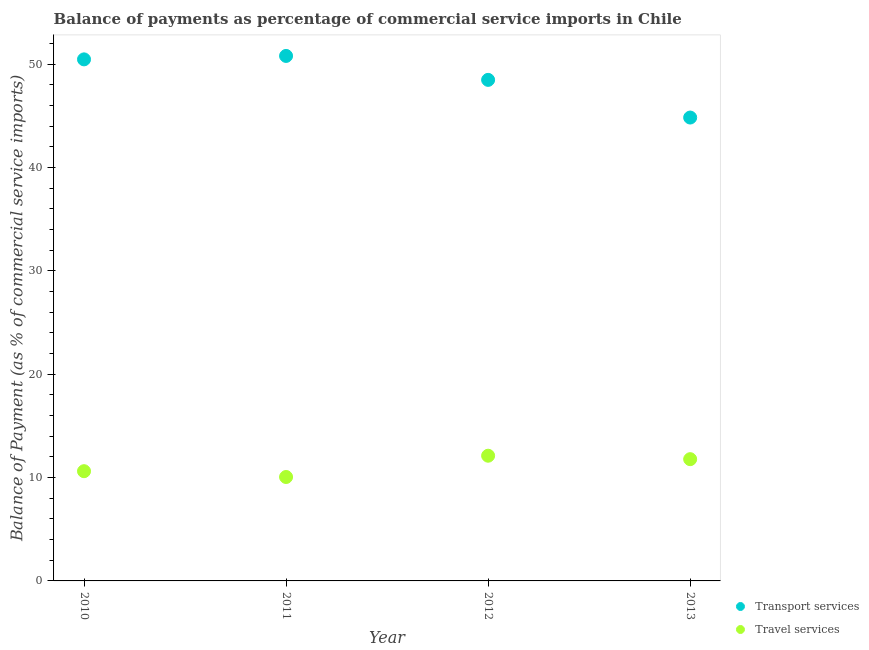How many different coloured dotlines are there?
Give a very brief answer. 2. What is the balance of payments of transport services in 2011?
Provide a succinct answer. 50.78. Across all years, what is the maximum balance of payments of travel services?
Offer a very short reply. 12.11. Across all years, what is the minimum balance of payments of transport services?
Your answer should be very brief. 44.82. In which year was the balance of payments of travel services maximum?
Offer a terse response. 2012. What is the total balance of payments of travel services in the graph?
Provide a succinct answer. 44.56. What is the difference between the balance of payments of travel services in 2010 and that in 2013?
Provide a short and direct response. -1.16. What is the difference between the balance of payments of transport services in 2010 and the balance of payments of travel services in 2012?
Your response must be concise. 38.34. What is the average balance of payments of transport services per year?
Keep it short and to the point. 48.63. In the year 2010, what is the difference between the balance of payments of transport services and balance of payments of travel services?
Offer a very short reply. 39.84. What is the ratio of the balance of payments of transport services in 2011 to that in 2012?
Give a very brief answer. 1.05. What is the difference between the highest and the second highest balance of payments of transport services?
Ensure brevity in your answer.  0.33. What is the difference between the highest and the lowest balance of payments of transport services?
Provide a succinct answer. 5.96. In how many years, is the balance of payments of transport services greater than the average balance of payments of transport services taken over all years?
Offer a terse response. 2. Is the balance of payments of transport services strictly greater than the balance of payments of travel services over the years?
Make the answer very short. Yes. How many dotlines are there?
Make the answer very short. 2. What is the difference between two consecutive major ticks on the Y-axis?
Offer a terse response. 10. Does the graph contain any zero values?
Offer a very short reply. No. Where does the legend appear in the graph?
Keep it short and to the point. Bottom right. How many legend labels are there?
Offer a very short reply. 2. How are the legend labels stacked?
Provide a short and direct response. Vertical. What is the title of the graph?
Offer a very short reply. Balance of payments as percentage of commercial service imports in Chile. Does "Mineral" appear as one of the legend labels in the graph?
Your answer should be very brief. No. What is the label or title of the X-axis?
Keep it short and to the point. Year. What is the label or title of the Y-axis?
Provide a short and direct response. Balance of Payment (as % of commercial service imports). What is the Balance of Payment (as % of commercial service imports) of Transport services in 2010?
Give a very brief answer. 50.45. What is the Balance of Payment (as % of commercial service imports) in Travel services in 2010?
Your answer should be very brief. 10.61. What is the Balance of Payment (as % of commercial service imports) in Transport services in 2011?
Offer a terse response. 50.78. What is the Balance of Payment (as % of commercial service imports) of Travel services in 2011?
Provide a short and direct response. 10.05. What is the Balance of Payment (as % of commercial service imports) in Transport services in 2012?
Ensure brevity in your answer.  48.47. What is the Balance of Payment (as % of commercial service imports) in Travel services in 2012?
Your answer should be very brief. 12.11. What is the Balance of Payment (as % of commercial service imports) in Transport services in 2013?
Your response must be concise. 44.82. What is the Balance of Payment (as % of commercial service imports) of Travel services in 2013?
Your answer should be compact. 11.78. Across all years, what is the maximum Balance of Payment (as % of commercial service imports) in Transport services?
Provide a short and direct response. 50.78. Across all years, what is the maximum Balance of Payment (as % of commercial service imports) of Travel services?
Offer a terse response. 12.11. Across all years, what is the minimum Balance of Payment (as % of commercial service imports) of Transport services?
Provide a short and direct response. 44.82. Across all years, what is the minimum Balance of Payment (as % of commercial service imports) in Travel services?
Your answer should be very brief. 10.05. What is the total Balance of Payment (as % of commercial service imports) in Transport services in the graph?
Your response must be concise. 194.53. What is the total Balance of Payment (as % of commercial service imports) in Travel services in the graph?
Make the answer very short. 44.56. What is the difference between the Balance of Payment (as % of commercial service imports) in Transport services in 2010 and that in 2011?
Your response must be concise. -0.33. What is the difference between the Balance of Payment (as % of commercial service imports) in Travel services in 2010 and that in 2011?
Your answer should be compact. 0.56. What is the difference between the Balance of Payment (as % of commercial service imports) of Transport services in 2010 and that in 2012?
Offer a terse response. 1.98. What is the difference between the Balance of Payment (as % of commercial service imports) in Travel services in 2010 and that in 2012?
Your answer should be compact. -1.5. What is the difference between the Balance of Payment (as % of commercial service imports) in Transport services in 2010 and that in 2013?
Keep it short and to the point. 5.63. What is the difference between the Balance of Payment (as % of commercial service imports) of Travel services in 2010 and that in 2013?
Provide a succinct answer. -1.16. What is the difference between the Balance of Payment (as % of commercial service imports) in Transport services in 2011 and that in 2012?
Give a very brief answer. 2.32. What is the difference between the Balance of Payment (as % of commercial service imports) of Travel services in 2011 and that in 2012?
Provide a short and direct response. -2.06. What is the difference between the Balance of Payment (as % of commercial service imports) in Transport services in 2011 and that in 2013?
Provide a short and direct response. 5.96. What is the difference between the Balance of Payment (as % of commercial service imports) of Travel services in 2011 and that in 2013?
Provide a succinct answer. -1.73. What is the difference between the Balance of Payment (as % of commercial service imports) of Transport services in 2012 and that in 2013?
Provide a short and direct response. 3.64. What is the difference between the Balance of Payment (as % of commercial service imports) of Travel services in 2012 and that in 2013?
Give a very brief answer. 0.33. What is the difference between the Balance of Payment (as % of commercial service imports) of Transport services in 2010 and the Balance of Payment (as % of commercial service imports) of Travel services in 2011?
Ensure brevity in your answer.  40.4. What is the difference between the Balance of Payment (as % of commercial service imports) of Transport services in 2010 and the Balance of Payment (as % of commercial service imports) of Travel services in 2012?
Your answer should be very brief. 38.34. What is the difference between the Balance of Payment (as % of commercial service imports) of Transport services in 2010 and the Balance of Payment (as % of commercial service imports) of Travel services in 2013?
Your answer should be very brief. 38.67. What is the difference between the Balance of Payment (as % of commercial service imports) in Transport services in 2011 and the Balance of Payment (as % of commercial service imports) in Travel services in 2012?
Keep it short and to the point. 38.67. What is the difference between the Balance of Payment (as % of commercial service imports) of Transport services in 2011 and the Balance of Payment (as % of commercial service imports) of Travel services in 2013?
Offer a very short reply. 39.01. What is the difference between the Balance of Payment (as % of commercial service imports) of Transport services in 2012 and the Balance of Payment (as % of commercial service imports) of Travel services in 2013?
Provide a short and direct response. 36.69. What is the average Balance of Payment (as % of commercial service imports) of Transport services per year?
Provide a succinct answer. 48.63. What is the average Balance of Payment (as % of commercial service imports) in Travel services per year?
Provide a short and direct response. 11.14. In the year 2010, what is the difference between the Balance of Payment (as % of commercial service imports) of Transport services and Balance of Payment (as % of commercial service imports) of Travel services?
Make the answer very short. 39.84. In the year 2011, what is the difference between the Balance of Payment (as % of commercial service imports) of Transport services and Balance of Payment (as % of commercial service imports) of Travel services?
Your answer should be compact. 40.73. In the year 2012, what is the difference between the Balance of Payment (as % of commercial service imports) of Transport services and Balance of Payment (as % of commercial service imports) of Travel services?
Make the answer very short. 36.36. In the year 2013, what is the difference between the Balance of Payment (as % of commercial service imports) of Transport services and Balance of Payment (as % of commercial service imports) of Travel services?
Your response must be concise. 33.05. What is the ratio of the Balance of Payment (as % of commercial service imports) of Transport services in 2010 to that in 2011?
Your answer should be very brief. 0.99. What is the ratio of the Balance of Payment (as % of commercial service imports) in Travel services in 2010 to that in 2011?
Your answer should be compact. 1.06. What is the ratio of the Balance of Payment (as % of commercial service imports) of Transport services in 2010 to that in 2012?
Ensure brevity in your answer.  1.04. What is the ratio of the Balance of Payment (as % of commercial service imports) in Travel services in 2010 to that in 2012?
Provide a short and direct response. 0.88. What is the ratio of the Balance of Payment (as % of commercial service imports) in Transport services in 2010 to that in 2013?
Your response must be concise. 1.13. What is the ratio of the Balance of Payment (as % of commercial service imports) in Travel services in 2010 to that in 2013?
Ensure brevity in your answer.  0.9. What is the ratio of the Balance of Payment (as % of commercial service imports) in Transport services in 2011 to that in 2012?
Your answer should be compact. 1.05. What is the ratio of the Balance of Payment (as % of commercial service imports) of Travel services in 2011 to that in 2012?
Provide a succinct answer. 0.83. What is the ratio of the Balance of Payment (as % of commercial service imports) of Transport services in 2011 to that in 2013?
Provide a short and direct response. 1.13. What is the ratio of the Balance of Payment (as % of commercial service imports) of Travel services in 2011 to that in 2013?
Offer a very short reply. 0.85. What is the ratio of the Balance of Payment (as % of commercial service imports) in Transport services in 2012 to that in 2013?
Make the answer very short. 1.08. What is the ratio of the Balance of Payment (as % of commercial service imports) in Travel services in 2012 to that in 2013?
Your answer should be very brief. 1.03. What is the difference between the highest and the second highest Balance of Payment (as % of commercial service imports) in Transport services?
Give a very brief answer. 0.33. What is the difference between the highest and the second highest Balance of Payment (as % of commercial service imports) in Travel services?
Your answer should be compact. 0.33. What is the difference between the highest and the lowest Balance of Payment (as % of commercial service imports) of Transport services?
Give a very brief answer. 5.96. What is the difference between the highest and the lowest Balance of Payment (as % of commercial service imports) in Travel services?
Provide a succinct answer. 2.06. 